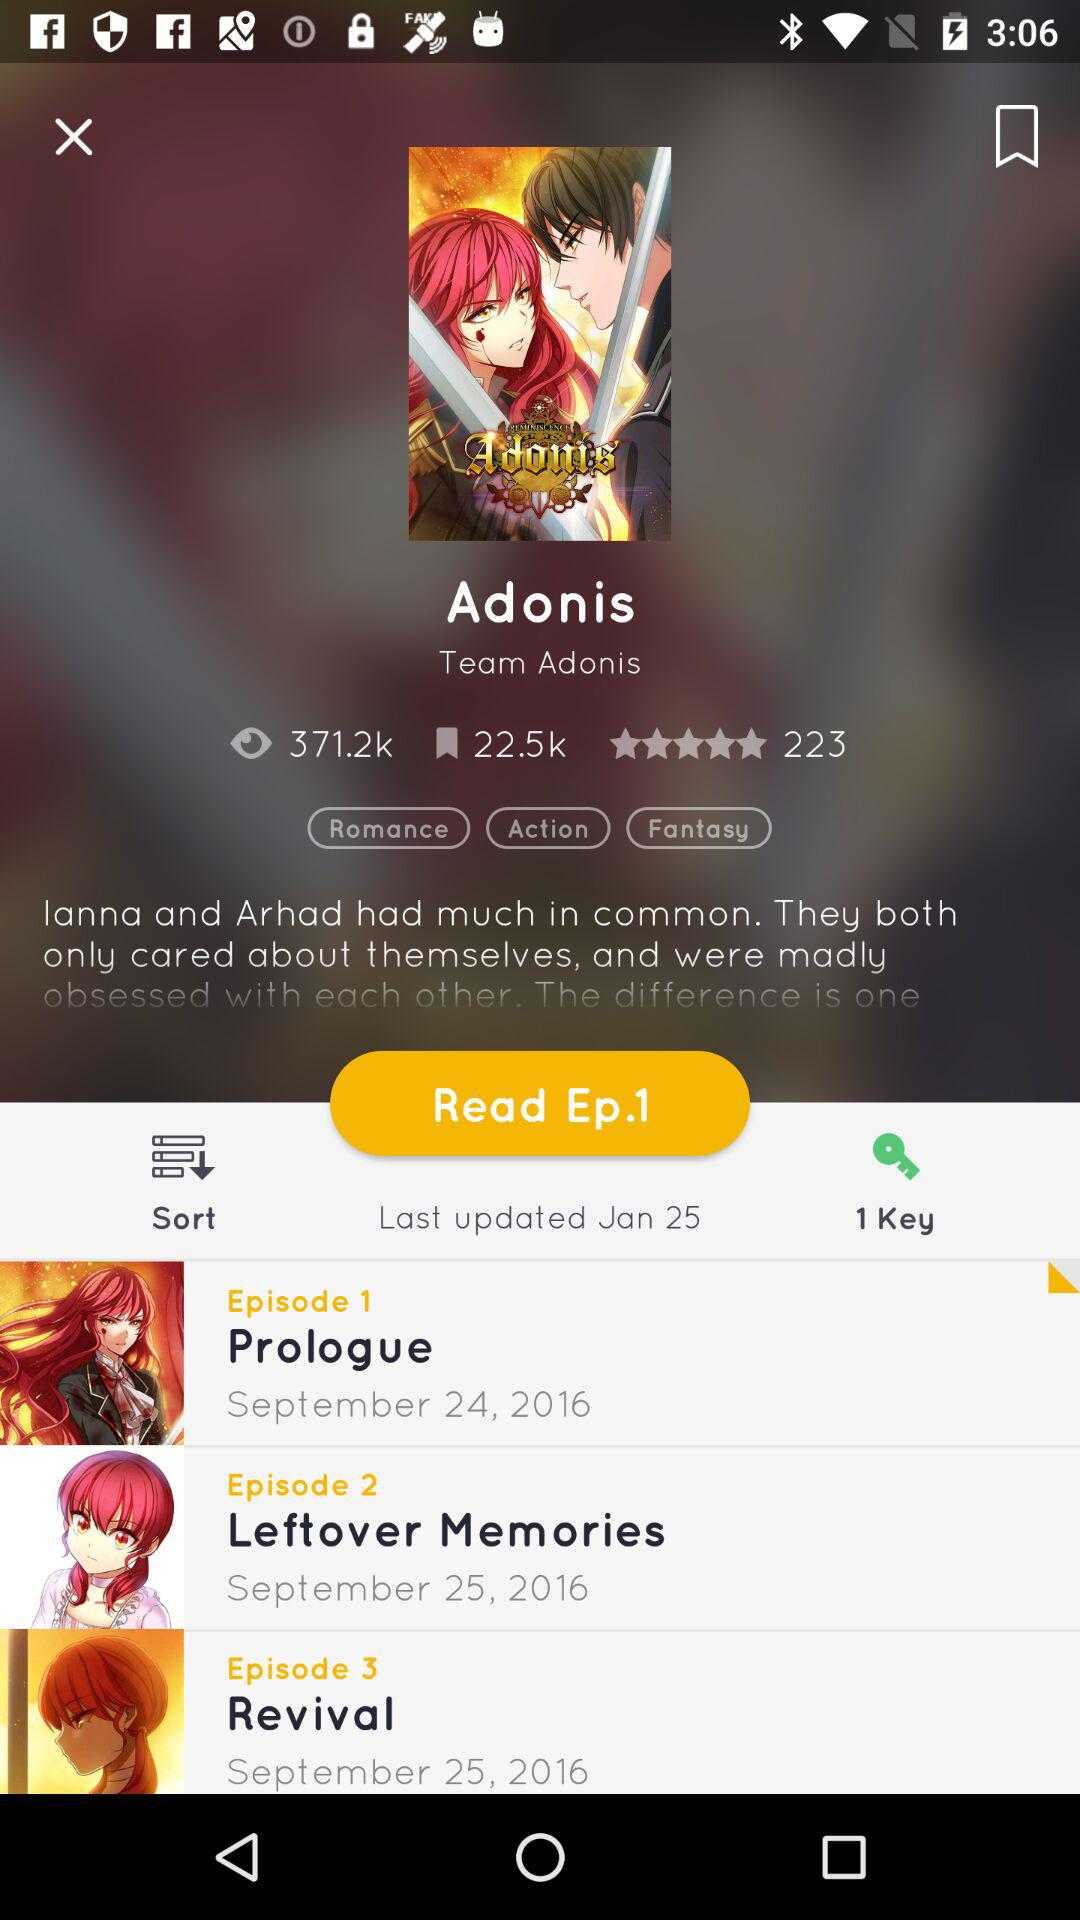How many keys are there? There is 1 key. 